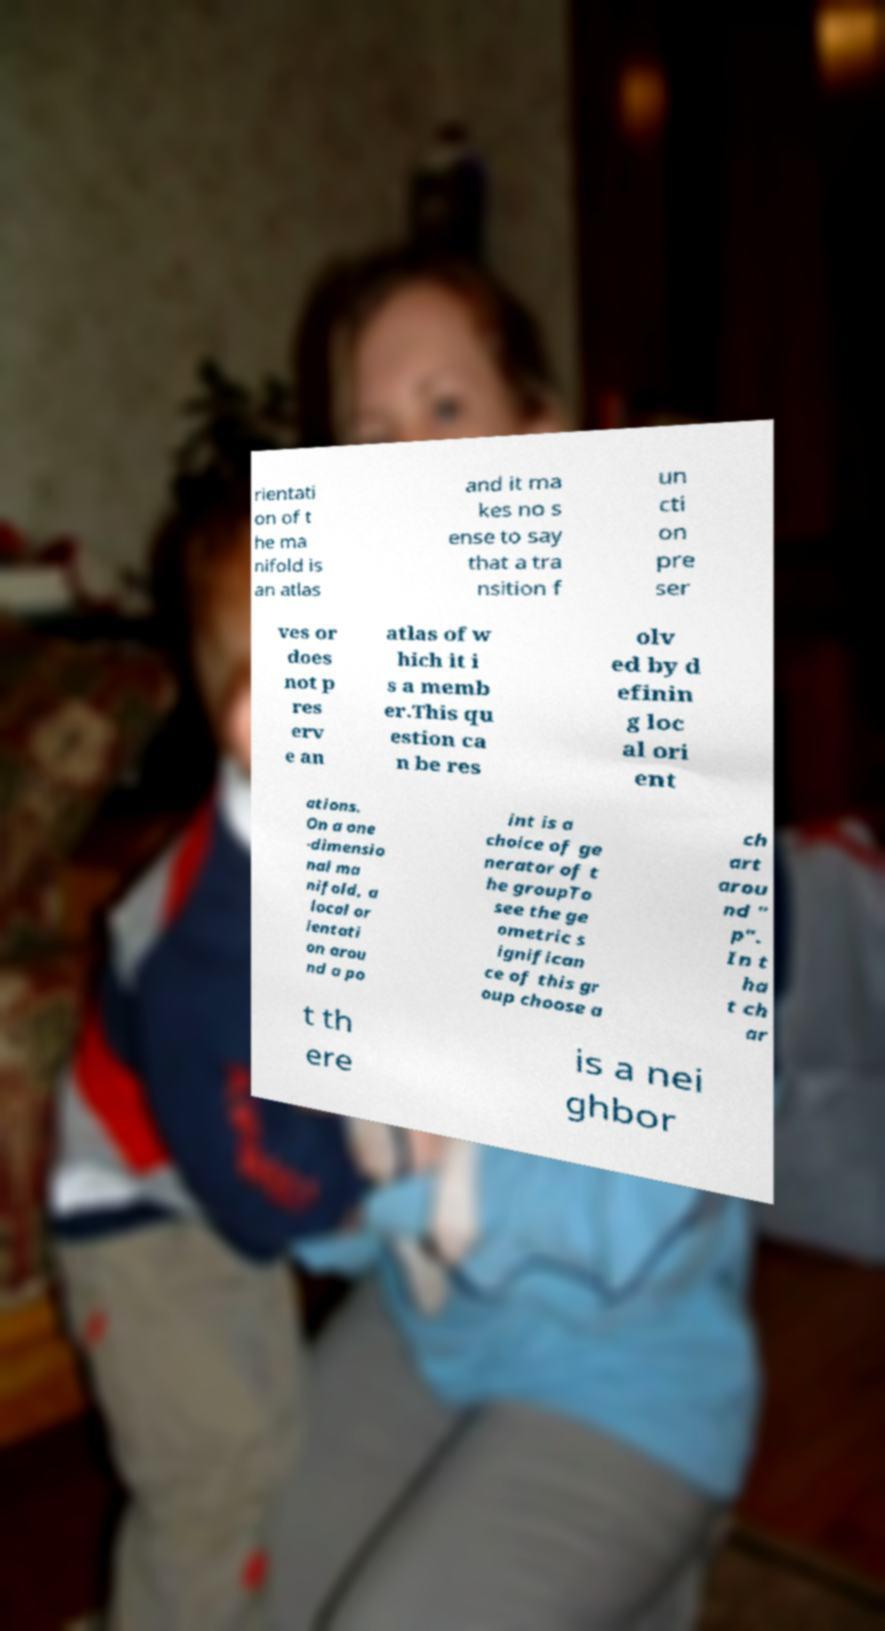I need the written content from this picture converted into text. Can you do that? rientati on of t he ma nifold is an atlas and it ma kes no s ense to say that a tra nsition f un cti on pre ser ves or does not p res erv e an atlas of w hich it i s a memb er.This qu estion ca n be res olv ed by d efinin g loc al ori ent ations. On a one -dimensio nal ma nifold, a local or ientati on arou nd a po int is a choice of ge nerator of t he groupTo see the ge ometric s ignifican ce of this gr oup choose a ch art arou nd " p". In t ha t ch ar t th ere is a nei ghbor 